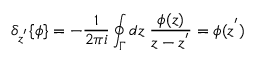<formula> <loc_0><loc_0><loc_500><loc_500>{ \delta } _ { z ^ { ^ { \prime } } } \{ \phi \} = - \frac { 1 } { 2 \pi i } \oint _ { \Gamma } d z \, \frac { \phi ( z ) } { z - z ^ { ^ { \prime } } } = \phi ( z ^ { ^ { \prime } } )</formula> 